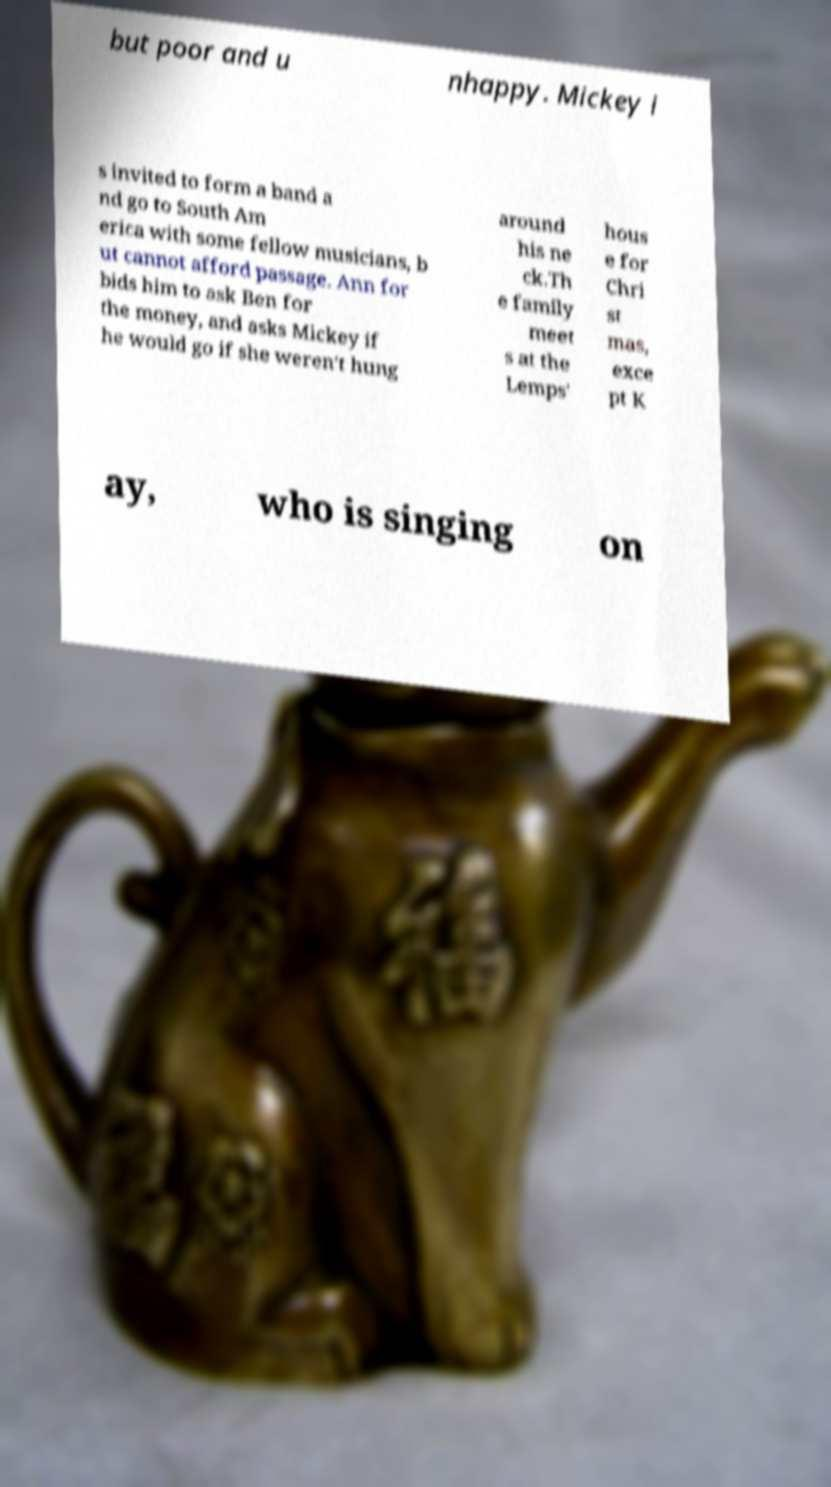Can you read and provide the text displayed in the image?This photo seems to have some interesting text. Can you extract and type it out for me? but poor and u nhappy. Mickey i s invited to form a band a nd go to South Am erica with some fellow musicians, b ut cannot afford passage. Ann for bids him to ask Ben for the money, and asks Mickey if he would go if she weren't hung around his ne ck.Th e family meet s at the Lemps' hous e for Chri st mas, exce pt K ay, who is singing on 